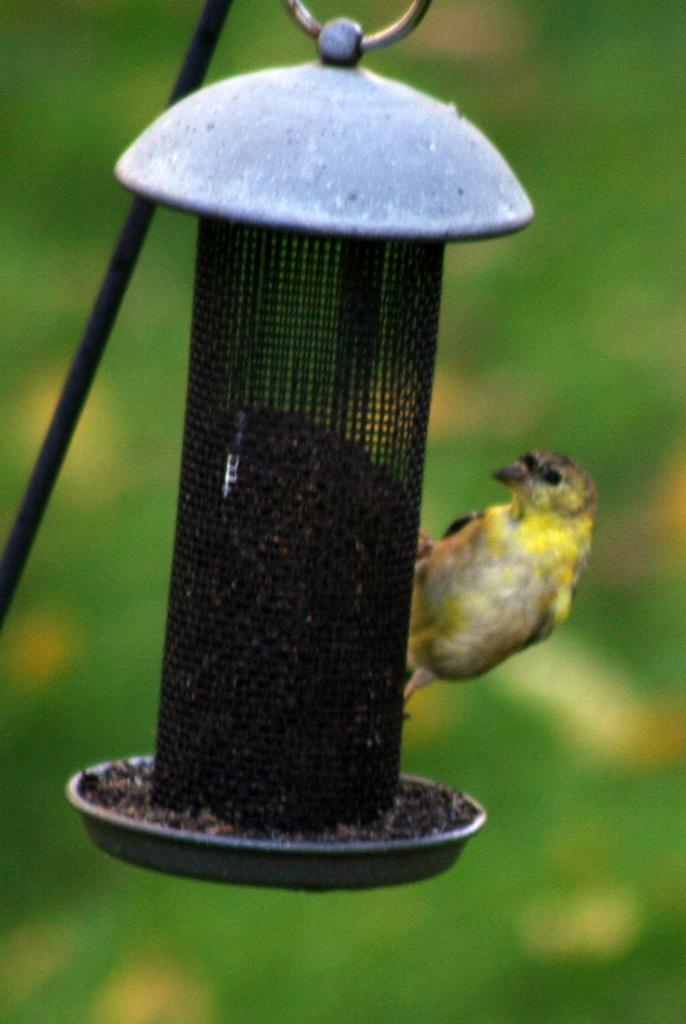What is the main subject in the image? There is an object in the image. Can you describe any specific features of the object? There is a rod in the image. What type of animal can be seen in the image? There is a bird in the image. What can be seen in the background of the image? There are trees in the background of the image. What hobbies does the plant in the image enjoy? There is no plant present in the image, so it is not possible to determine any hobbies it might enjoy. 